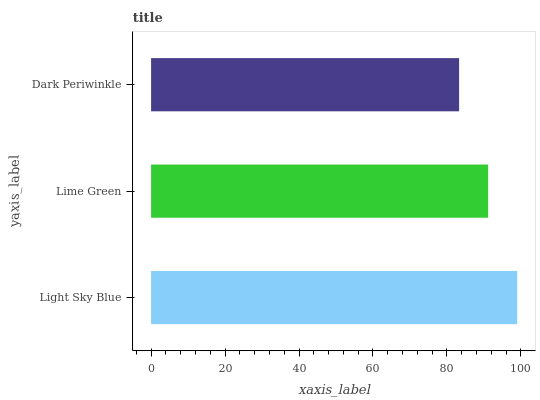Is Dark Periwinkle the minimum?
Answer yes or no. Yes. Is Light Sky Blue the maximum?
Answer yes or no. Yes. Is Lime Green the minimum?
Answer yes or no. No. Is Lime Green the maximum?
Answer yes or no. No. Is Light Sky Blue greater than Lime Green?
Answer yes or no. Yes. Is Lime Green less than Light Sky Blue?
Answer yes or no. Yes. Is Lime Green greater than Light Sky Blue?
Answer yes or no. No. Is Light Sky Blue less than Lime Green?
Answer yes or no. No. Is Lime Green the high median?
Answer yes or no. Yes. Is Lime Green the low median?
Answer yes or no. Yes. Is Dark Periwinkle the high median?
Answer yes or no. No. Is Light Sky Blue the low median?
Answer yes or no. No. 